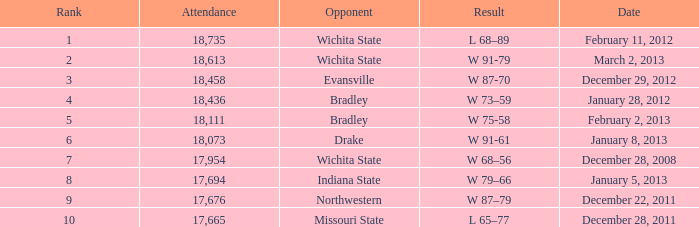What's the standing when the number of attendees was under 18,073 and with northwestern as the competitor? 9.0. 